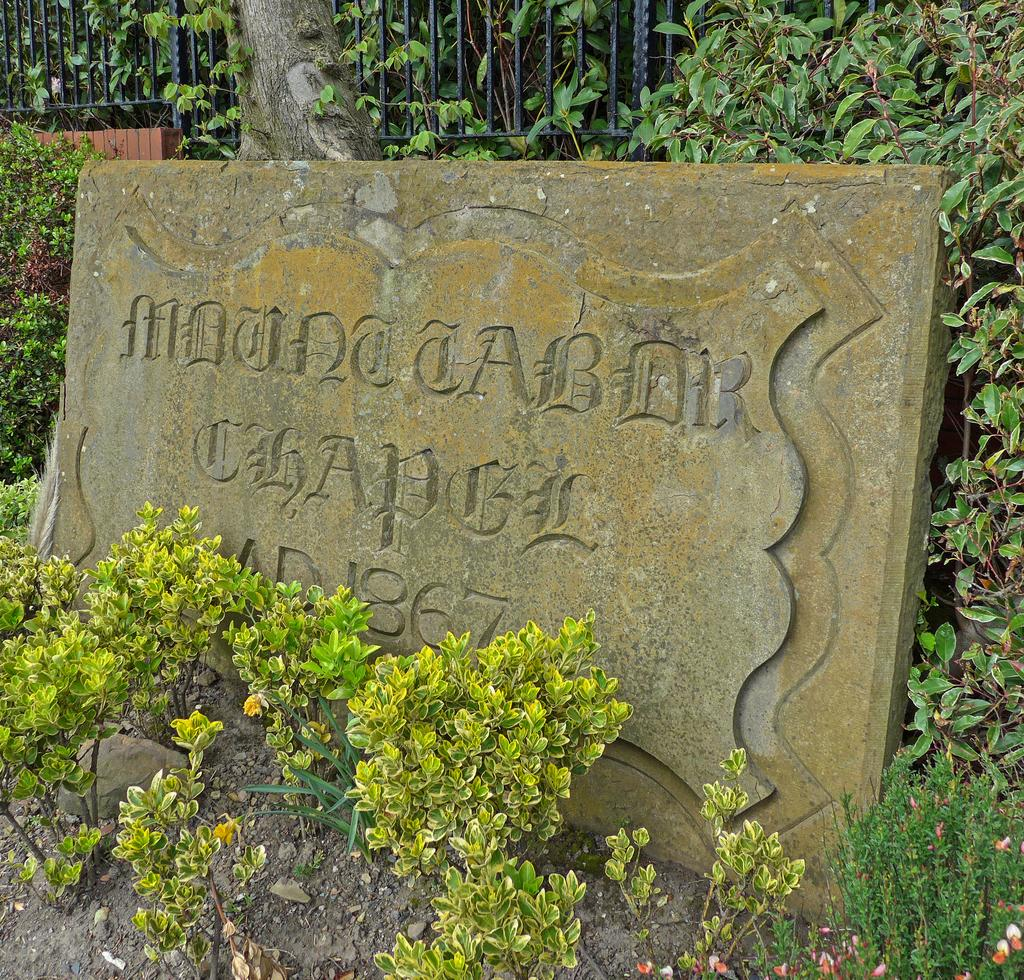What is the main object in the image? There is a stone board in the image. What else can be seen in the image besides the stone board? There are plants and a fence in the image. What color is the orange in the image? There is no orange present in the image. What type of camera can be seen capturing the scene in the image? There is no camera visible in the image. 